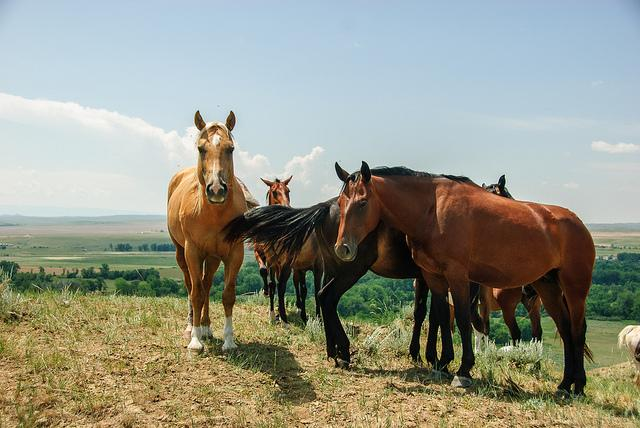What is above the horses? Please explain your reasoning. sky. The horses have the sky above them. 